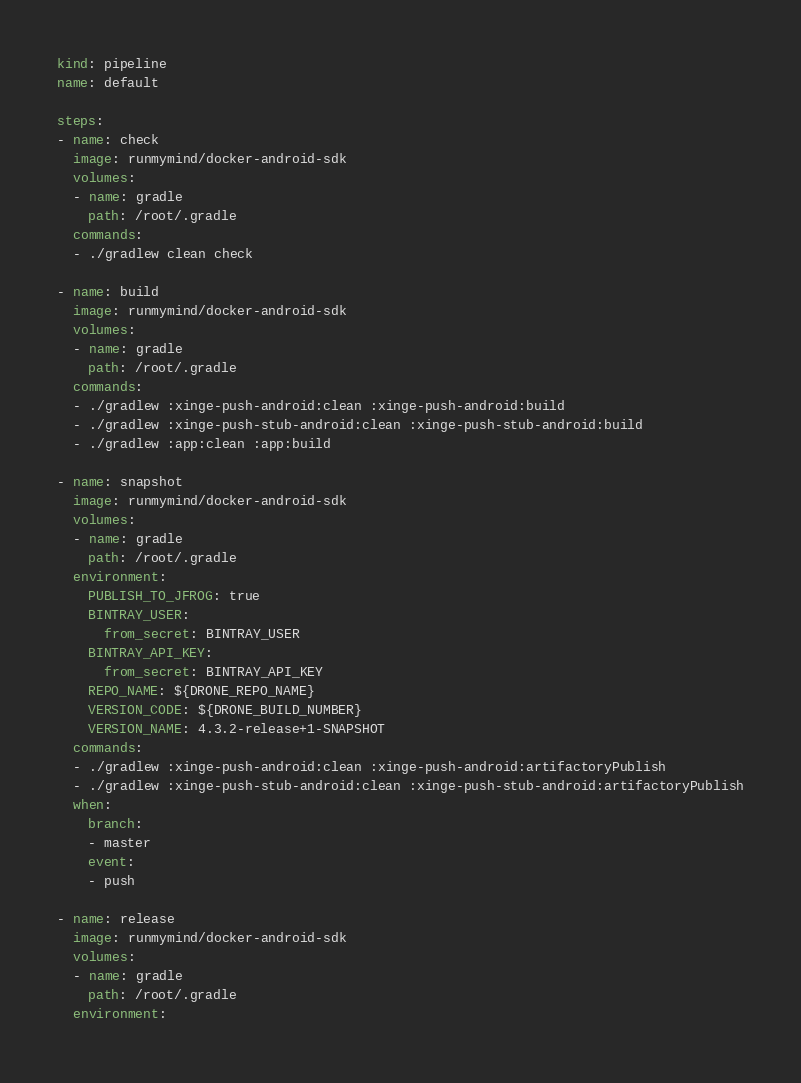Convert code to text. <code><loc_0><loc_0><loc_500><loc_500><_YAML_>kind: pipeline
name: default

steps:
- name: check
  image: runmymind/docker-android-sdk
  volumes:
  - name: gradle
    path: /root/.gradle
  commands:
  - ./gradlew clean check

- name: build
  image: runmymind/docker-android-sdk
  volumes:
  - name: gradle
    path: /root/.gradle
  commands:
  - ./gradlew :xinge-push-android:clean :xinge-push-android:build
  - ./gradlew :xinge-push-stub-android:clean :xinge-push-stub-android:build
  - ./gradlew :app:clean :app:build

- name: snapshot
  image: runmymind/docker-android-sdk
  volumes:
  - name: gradle
    path: /root/.gradle
  environment:
    PUBLISH_TO_JFROG: true
    BINTRAY_USER:
      from_secret: BINTRAY_USER
    BINTRAY_API_KEY:
      from_secret: BINTRAY_API_KEY
    REPO_NAME: ${DRONE_REPO_NAME}
    VERSION_CODE: ${DRONE_BUILD_NUMBER}
    VERSION_NAME: 4.3.2-release+1-SNAPSHOT
  commands:
  - ./gradlew :xinge-push-android:clean :xinge-push-android:artifactoryPublish
  - ./gradlew :xinge-push-stub-android:clean :xinge-push-stub-android:artifactoryPublish
  when:
    branch:
    - master
    event:
    - push

- name: release
  image: runmymind/docker-android-sdk
  volumes:
  - name: gradle
    path: /root/.gradle
  environment:</code> 